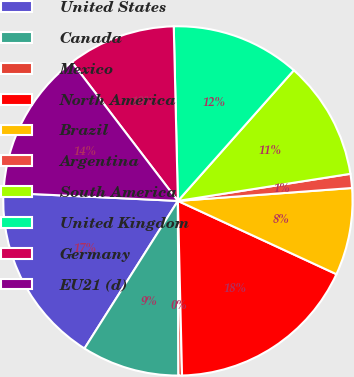Convert chart. <chart><loc_0><loc_0><loc_500><loc_500><pie_chart><fcel>United States<fcel>Canada<fcel>Mexico<fcel>North America<fcel>Brazil<fcel>Argentina<fcel>South America<fcel>United Kingdom<fcel>Germany<fcel>EU21 (d)<nl><fcel>16.77%<fcel>9.03%<fcel>0.33%<fcel>17.73%<fcel>8.07%<fcel>1.3%<fcel>10.97%<fcel>11.93%<fcel>10.0%<fcel>13.87%<nl></chart> 